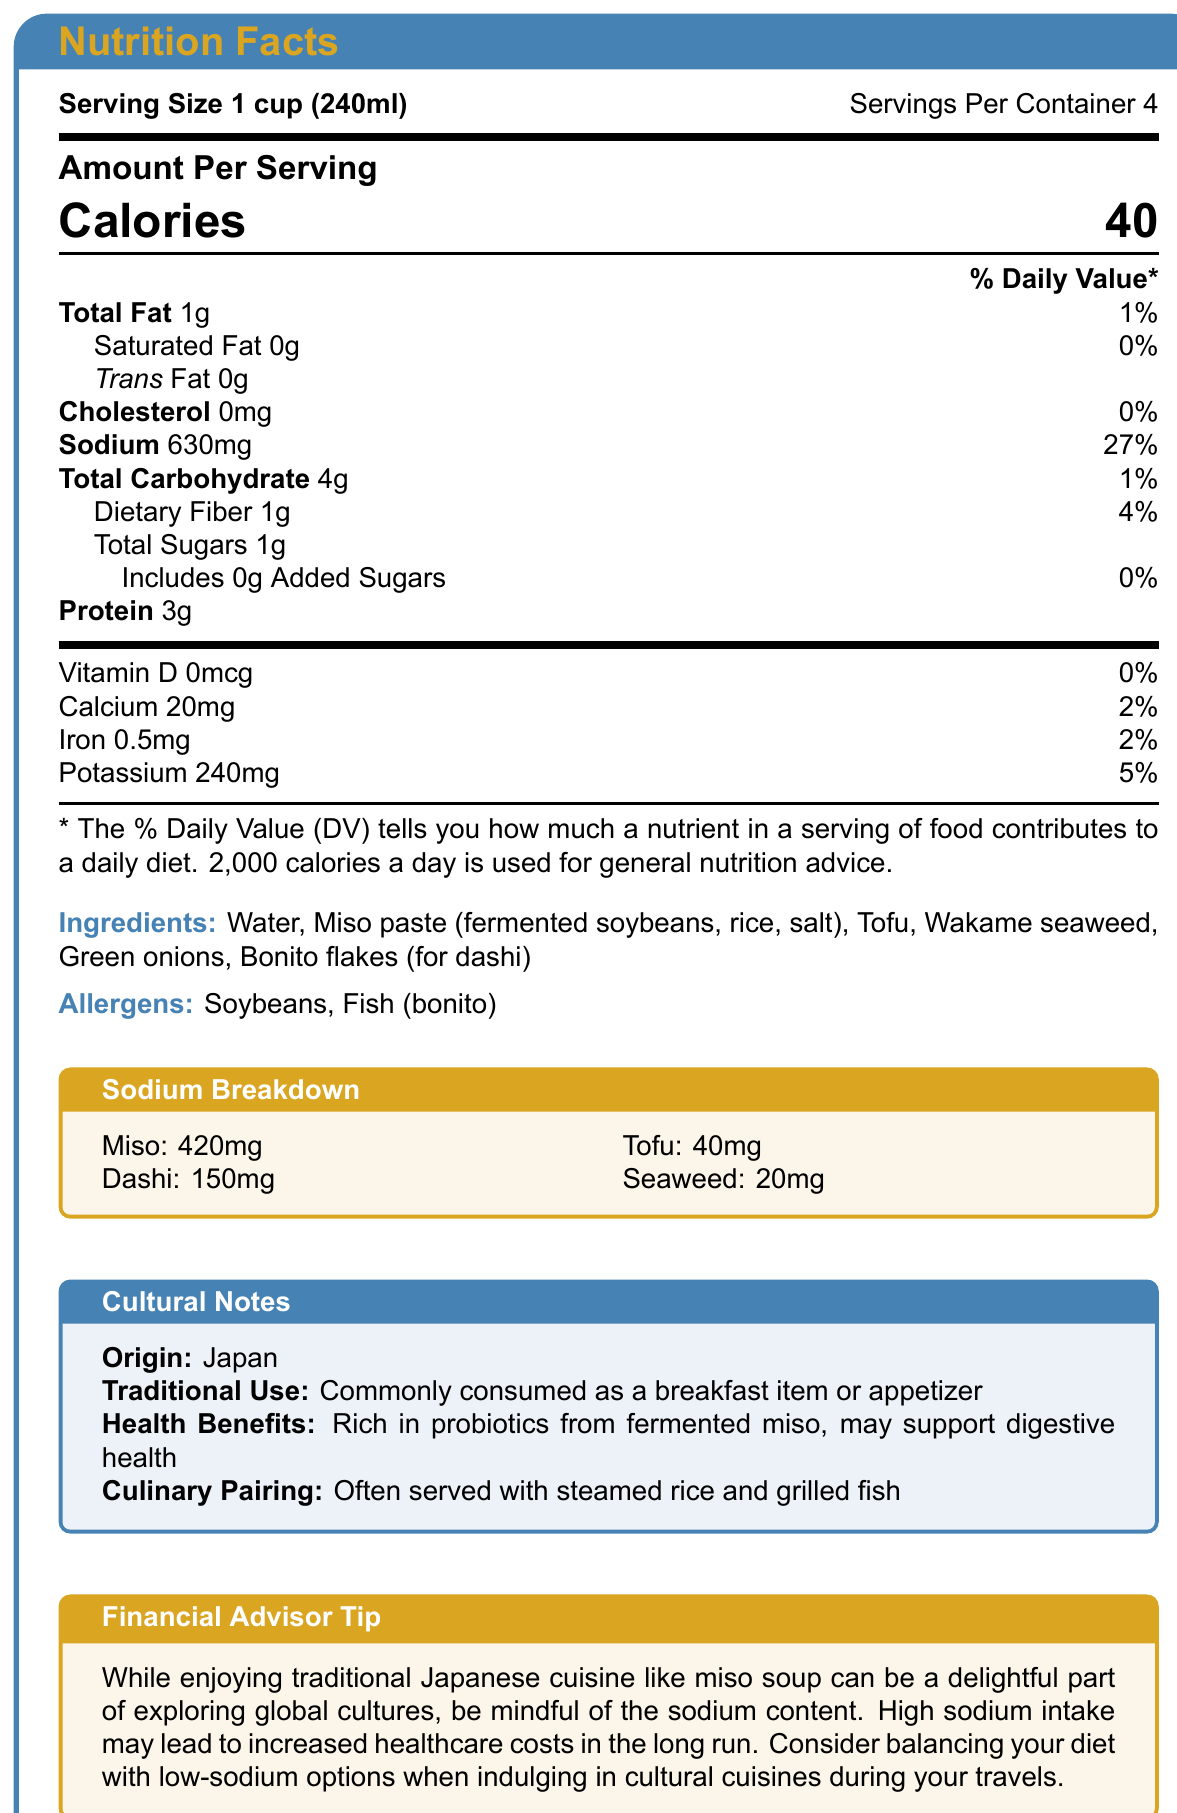what is the serving size of the miso soup? The document states that the serving size is "1 cup (240ml)".
Answer: 1 cup (240ml) how many calories are there per serving of miso soup? The document indicates that there are 40 calories per serving.
Answer: 40 which ingredient contributes the most sodium to the miso soup? The sodium breakdown section of the document shows that miso contributes 420mg of the total sodium, which is the highest amount compared to the other ingredients.
Answer: Miso how many servings are there in one container of miso soup? The document states that there are 4 servings per container.
Answer: 4 which ingredients are listed as allergens? The allergens section mentions that the miso soup contains soybeans and fish (bonito) as allergens.
Answer: Soybeans and Fish (bonito) what percentage of the daily value of sodium is in one serving of miso soup? A. 15% B. 20% C. 27% D. 30% The document lists the sodium amount as 630mg, which is 27% of the daily value.
Answer: C. 27% what health benefit is associated with the probiotics from fermented miso according to the cultural notes? A. Supports heart health B. Supports digestive health C. Supports brain health D. Supports bone health The cultural notes section mentions that the miso is rich in probiotics, which may support digestive health.
Answer: B. Supports digestive health is there any added sugar in the miso soup? The document specifically states that the added sugars amount is 0g, meaning there is no added sugar.
Answer: No can we determine the exact brand of miso soup from the document? The document provides details about the nutritional content and ingredients, but it does not disclose the brand of miso soup.
Answer: Not enough information summarize the main components and insights from the document. The document is a comprehensive nutrition label for miso soup, detailing the nutritional content per serving, including calorie count, fat, cholesterol, sodium, carbohydrates, fiber, sugars, protein, and vitamins and minerals. It also lists the ingredients, allergens, and provides cultural context. A special section elaborates on the sodium content from different ingredients. Finally, there is a financial advisory note regarding the implications of high sodium intake.
Answer: The document provides the nutritional facts of a traditional Japanese miso soup, including serving size, calories, and nutrient breakdown. It also highlights a detailed sodium content breakdown from different ingredients in the soup. The ingredients and allergens are listed, along with cultural notes about its origin, traditional use, health benefits, and culinary pairing. A financial advisor tip is included to advise on the potential long-term costs associated with high sodium intake. 